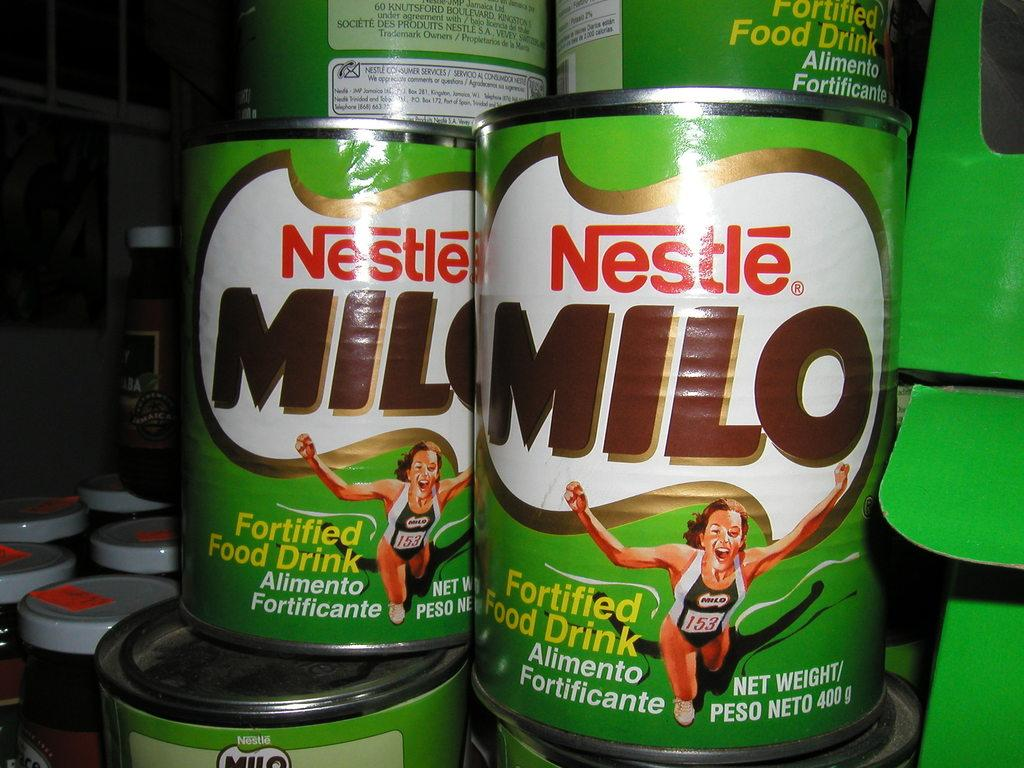<image>
Offer a succinct explanation of the picture presented. Stacked cans of Nestle Milo that show a woman runner on the label. 